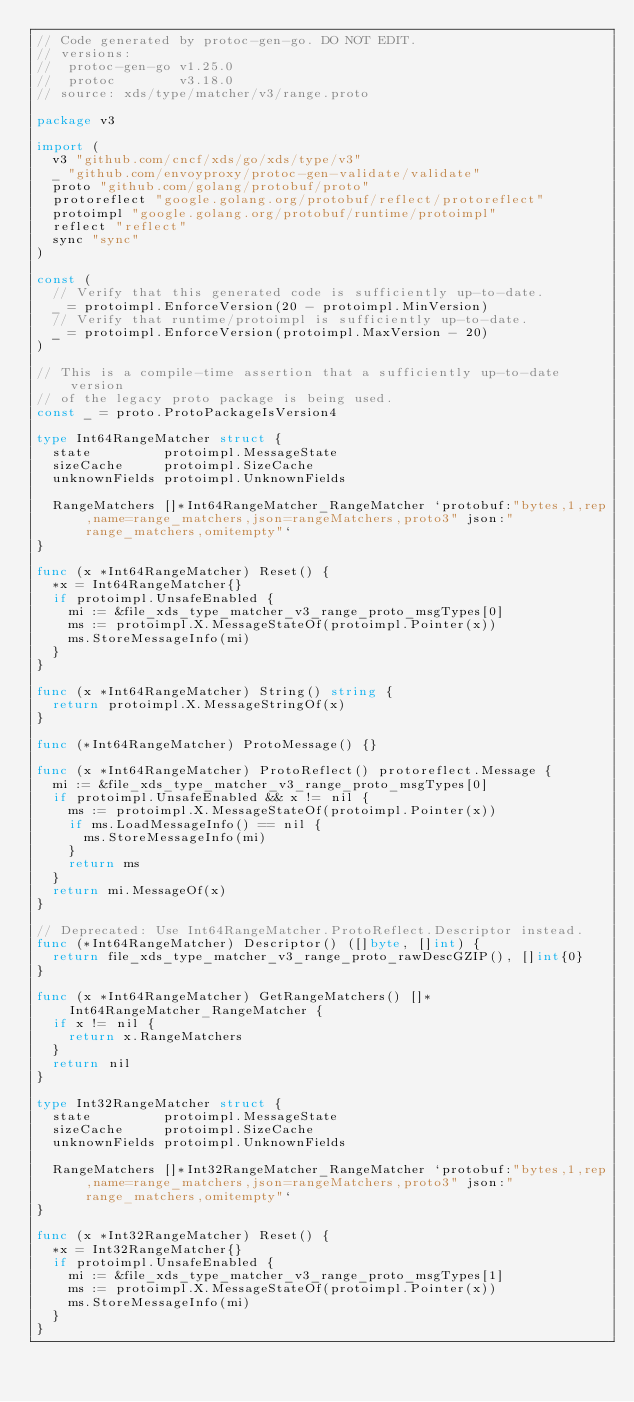Convert code to text. <code><loc_0><loc_0><loc_500><loc_500><_Go_>// Code generated by protoc-gen-go. DO NOT EDIT.
// versions:
// 	protoc-gen-go v1.25.0
// 	protoc        v3.18.0
// source: xds/type/matcher/v3/range.proto

package v3

import (
	v3 "github.com/cncf/xds/go/xds/type/v3"
	_ "github.com/envoyproxy/protoc-gen-validate/validate"
	proto "github.com/golang/protobuf/proto"
	protoreflect "google.golang.org/protobuf/reflect/protoreflect"
	protoimpl "google.golang.org/protobuf/runtime/protoimpl"
	reflect "reflect"
	sync "sync"
)

const (
	// Verify that this generated code is sufficiently up-to-date.
	_ = protoimpl.EnforceVersion(20 - protoimpl.MinVersion)
	// Verify that runtime/protoimpl is sufficiently up-to-date.
	_ = protoimpl.EnforceVersion(protoimpl.MaxVersion - 20)
)

// This is a compile-time assertion that a sufficiently up-to-date version
// of the legacy proto package is being used.
const _ = proto.ProtoPackageIsVersion4

type Int64RangeMatcher struct {
	state         protoimpl.MessageState
	sizeCache     protoimpl.SizeCache
	unknownFields protoimpl.UnknownFields

	RangeMatchers []*Int64RangeMatcher_RangeMatcher `protobuf:"bytes,1,rep,name=range_matchers,json=rangeMatchers,proto3" json:"range_matchers,omitempty"`
}

func (x *Int64RangeMatcher) Reset() {
	*x = Int64RangeMatcher{}
	if protoimpl.UnsafeEnabled {
		mi := &file_xds_type_matcher_v3_range_proto_msgTypes[0]
		ms := protoimpl.X.MessageStateOf(protoimpl.Pointer(x))
		ms.StoreMessageInfo(mi)
	}
}

func (x *Int64RangeMatcher) String() string {
	return protoimpl.X.MessageStringOf(x)
}

func (*Int64RangeMatcher) ProtoMessage() {}

func (x *Int64RangeMatcher) ProtoReflect() protoreflect.Message {
	mi := &file_xds_type_matcher_v3_range_proto_msgTypes[0]
	if protoimpl.UnsafeEnabled && x != nil {
		ms := protoimpl.X.MessageStateOf(protoimpl.Pointer(x))
		if ms.LoadMessageInfo() == nil {
			ms.StoreMessageInfo(mi)
		}
		return ms
	}
	return mi.MessageOf(x)
}

// Deprecated: Use Int64RangeMatcher.ProtoReflect.Descriptor instead.
func (*Int64RangeMatcher) Descriptor() ([]byte, []int) {
	return file_xds_type_matcher_v3_range_proto_rawDescGZIP(), []int{0}
}

func (x *Int64RangeMatcher) GetRangeMatchers() []*Int64RangeMatcher_RangeMatcher {
	if x != nil {
		return x.RangeMatchers
	}
	return nil
}

type Int32RangeMatcher struct {
	state         protoimpl.MessageState
	sizeCache     protoimpl.SizeCache
	unknownFields protoimpl.UnknownFields

	RangeMatchers []*Int32RangeMatcher_RangeMatcher `protobuf:"bytes,1,rep,name=range_matchers,json=rangeMatchers,proto3" json:"range_matchers,omitempty"`
}

func (x *Int32RangeMatcher) Reset() {
	*x = Int32RangeMatcher{}
	if protoimpl.UnsafeEnabled {
		mi := &file_xds_type_matcher_v3_range_proto_msgTypes[1]
		ms := protoimpl.X.MessageStateOf(protoimpl.Pointer(x))
		ms.StoreMessageInfo(mi)
	}
}
</code> 